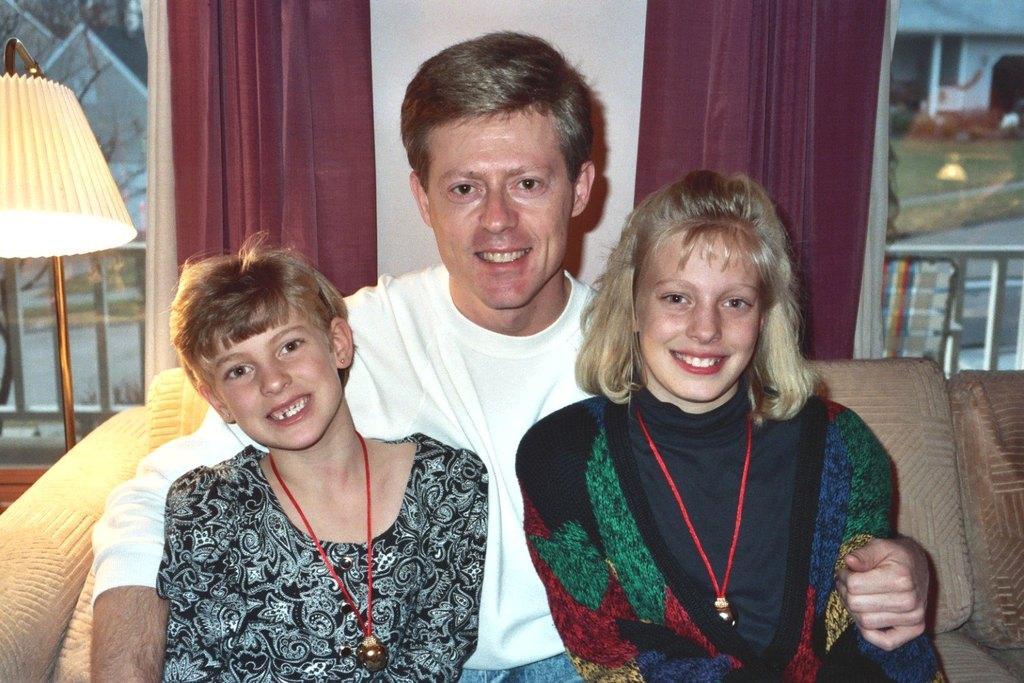Please provide a concise description of this image. In this image I can see three people sitting on the couch. These people are wearing the different color dresses and the couch is in brown color. To the left I can see the lamp. In the back there are maroon color curtains and I can see a frame to the wall. 